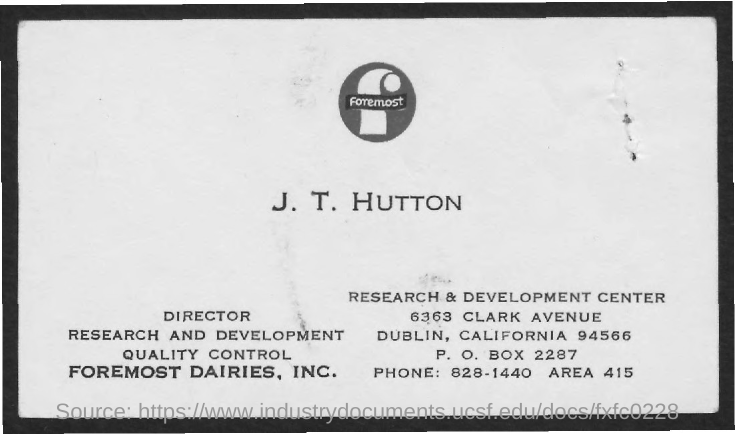What is the text written in the image?
Provide a short and direct response. Foremost. Who is the director of Research and Development Quality Control?
Provide a short and direct response. J. t. hutton. What is the PO Box Number mentioned in the document?
Your answer should be compact. 2287. What is the area number mentioned in the document?
Make the answer very short. 415. What is the phone number mentioned in the document?
Your response must be concise. 828-1440. 